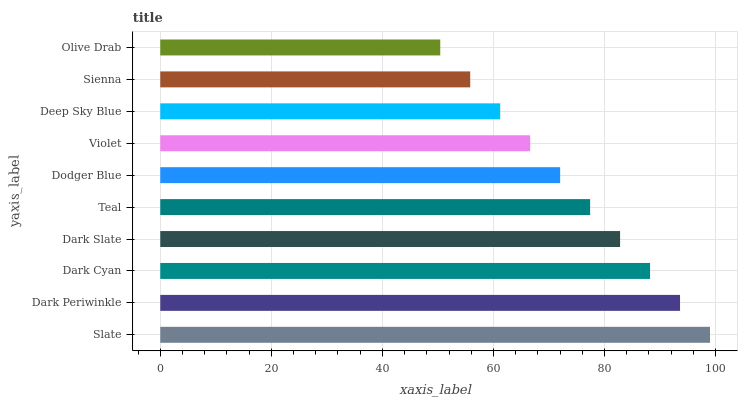Is Olive Drab the minimum?
Answer yes or no. Yes. Is Slate the maximum?
Answer yes or no. Yes. Is Dark Periwinkle the minimum?
Answer yes or no. No. Is Dark Periwinkle the maximum?
Answer yes or no. No. Is Slate greater than Dark Periwinkle?
Answer yes or no. Yes. Is Dark Periwinkle less than Slate?
Answer yes or no. Yes. Is Dark Periwinkle greater than Slate?
Answer yes or no. No. Is Slate less than Dark Periwinkle?
Answer yes or no. No. Is Teal the high median?
Answer yes or no. Yes. Is Dodger Blue the low median?
Answer yes or no. Yes. Is Dark Slate the high median?
Answer yes or no. No. Is Sienna the low median?
Answer yes or no. No. 